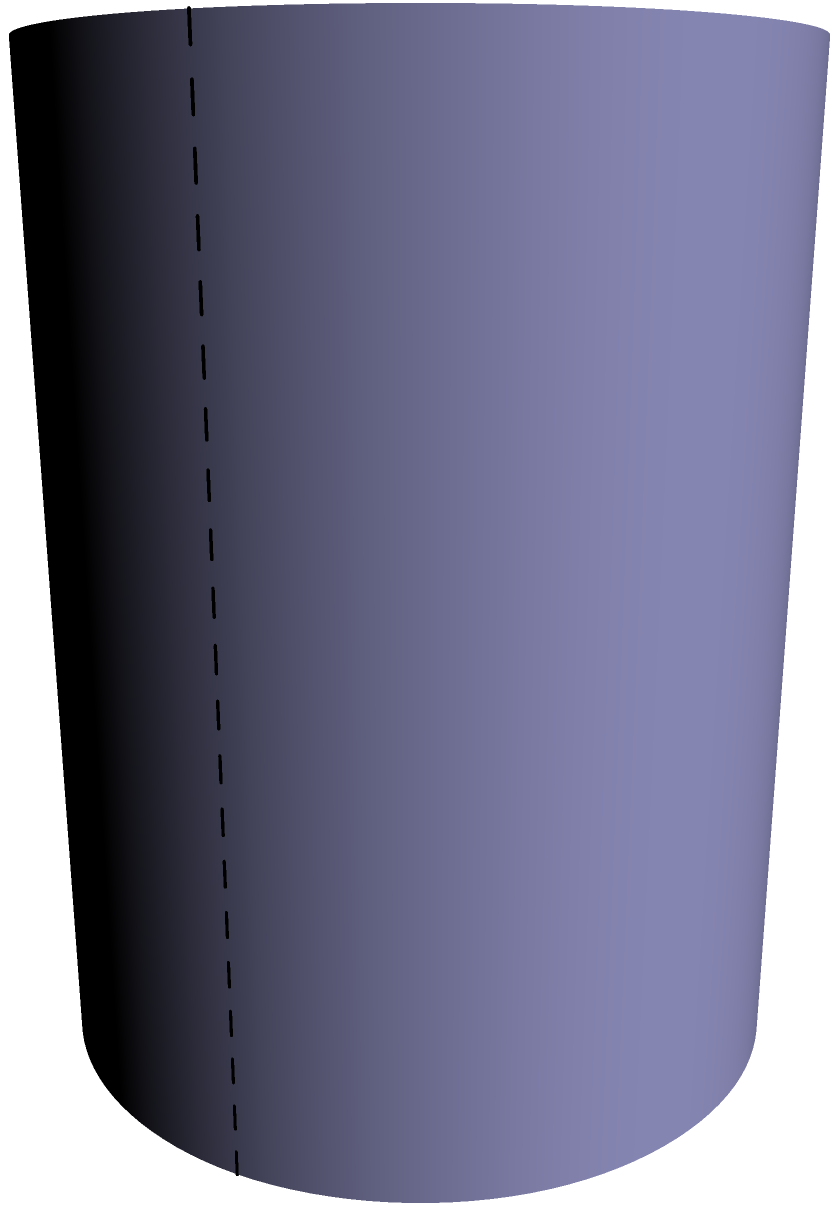As a statistician analyzing datasets from various industries, you encounter a problem involving the surface area of a cone. The cone has a height of 8 units and a base radius of 3 units. Calculate the total surface area of this cone, including its circular base. Round your answer to two decimal places. To solve this problem, we'll follow these steps:

1) The surface area of a cone consists of two parts:
   a) The lateral surface area (curved surface)
   b) The area of the circular base

2) For the lateral surface area, we need to calculate the slant height (s) using the Pythagorean theorem:
   $s = \sqrt{r^2 + h^2}$
   $s = \sqrt{3^2 + 8^2} = \sqrt{9 + 64} = \sqrt{73}$

3) The formula for the lateral surface area is:
   $A_{\text{lateral}} = \pi r s$
   $A_{\text{lateral}} = \pi \cdot 3 \cdot \sqrt{73}$

4) The area of the circular base is:
   $A_{\text{base}} = \pi r^2$
   $A_{\text{base}} = \pi \cdot 3^2 = 9\pi$

5) The total surface area is the sum of these two:
   $A_{\text{total}} = A_{\text{lateral}} + A_{\text{base}}$
   $A_{\text{total}} = \pi \cdot 3 \cdot \sqrt{73} + 9\pi$
   $A_{\text{total}} = 3\pi(\sqrt{73} + 3)$

6) Calculating this value:
   $A_{\text{total}} \approx 3 \cdot 3.14159 \cdot (8.54400 + 3) \approx 109.42$ square units

7) Rounding to two decimal places:
   $A_{\text{total}} \approx 109.42$ square units
Answer: 109.42 square units 